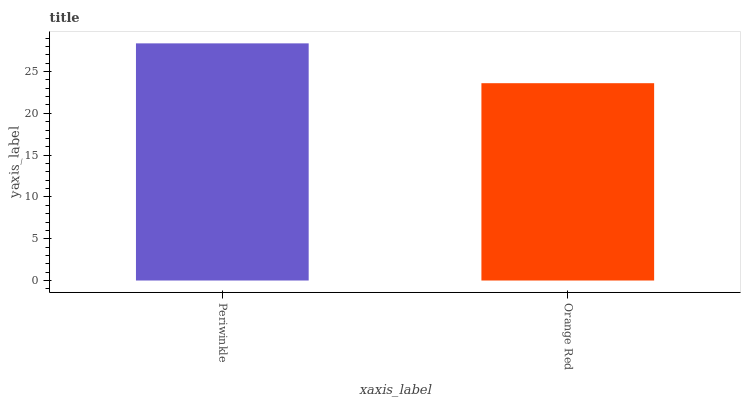Is Orange Red the maximum?
Answer yes or no. No. Is Periwinkle greater than Orange Red?
Answer yes or no. Yes. Is Orange Red less than Periwinkle?
Answer yes or no. Yes. Is Orange Red greater than Periwinkle?
Answer yes or no. No. Is Periwinkle less than Orange Red?
Answer yes or no. No. Is Periwinkle the high median?
Answer yes or no. Yes. Is Orange Red the low median?
Answer yes or no. Yes. Is Orange Red the high median?
Answer yes or no. No. Is Periwinkle the low median?
Answer yes or no. No. 